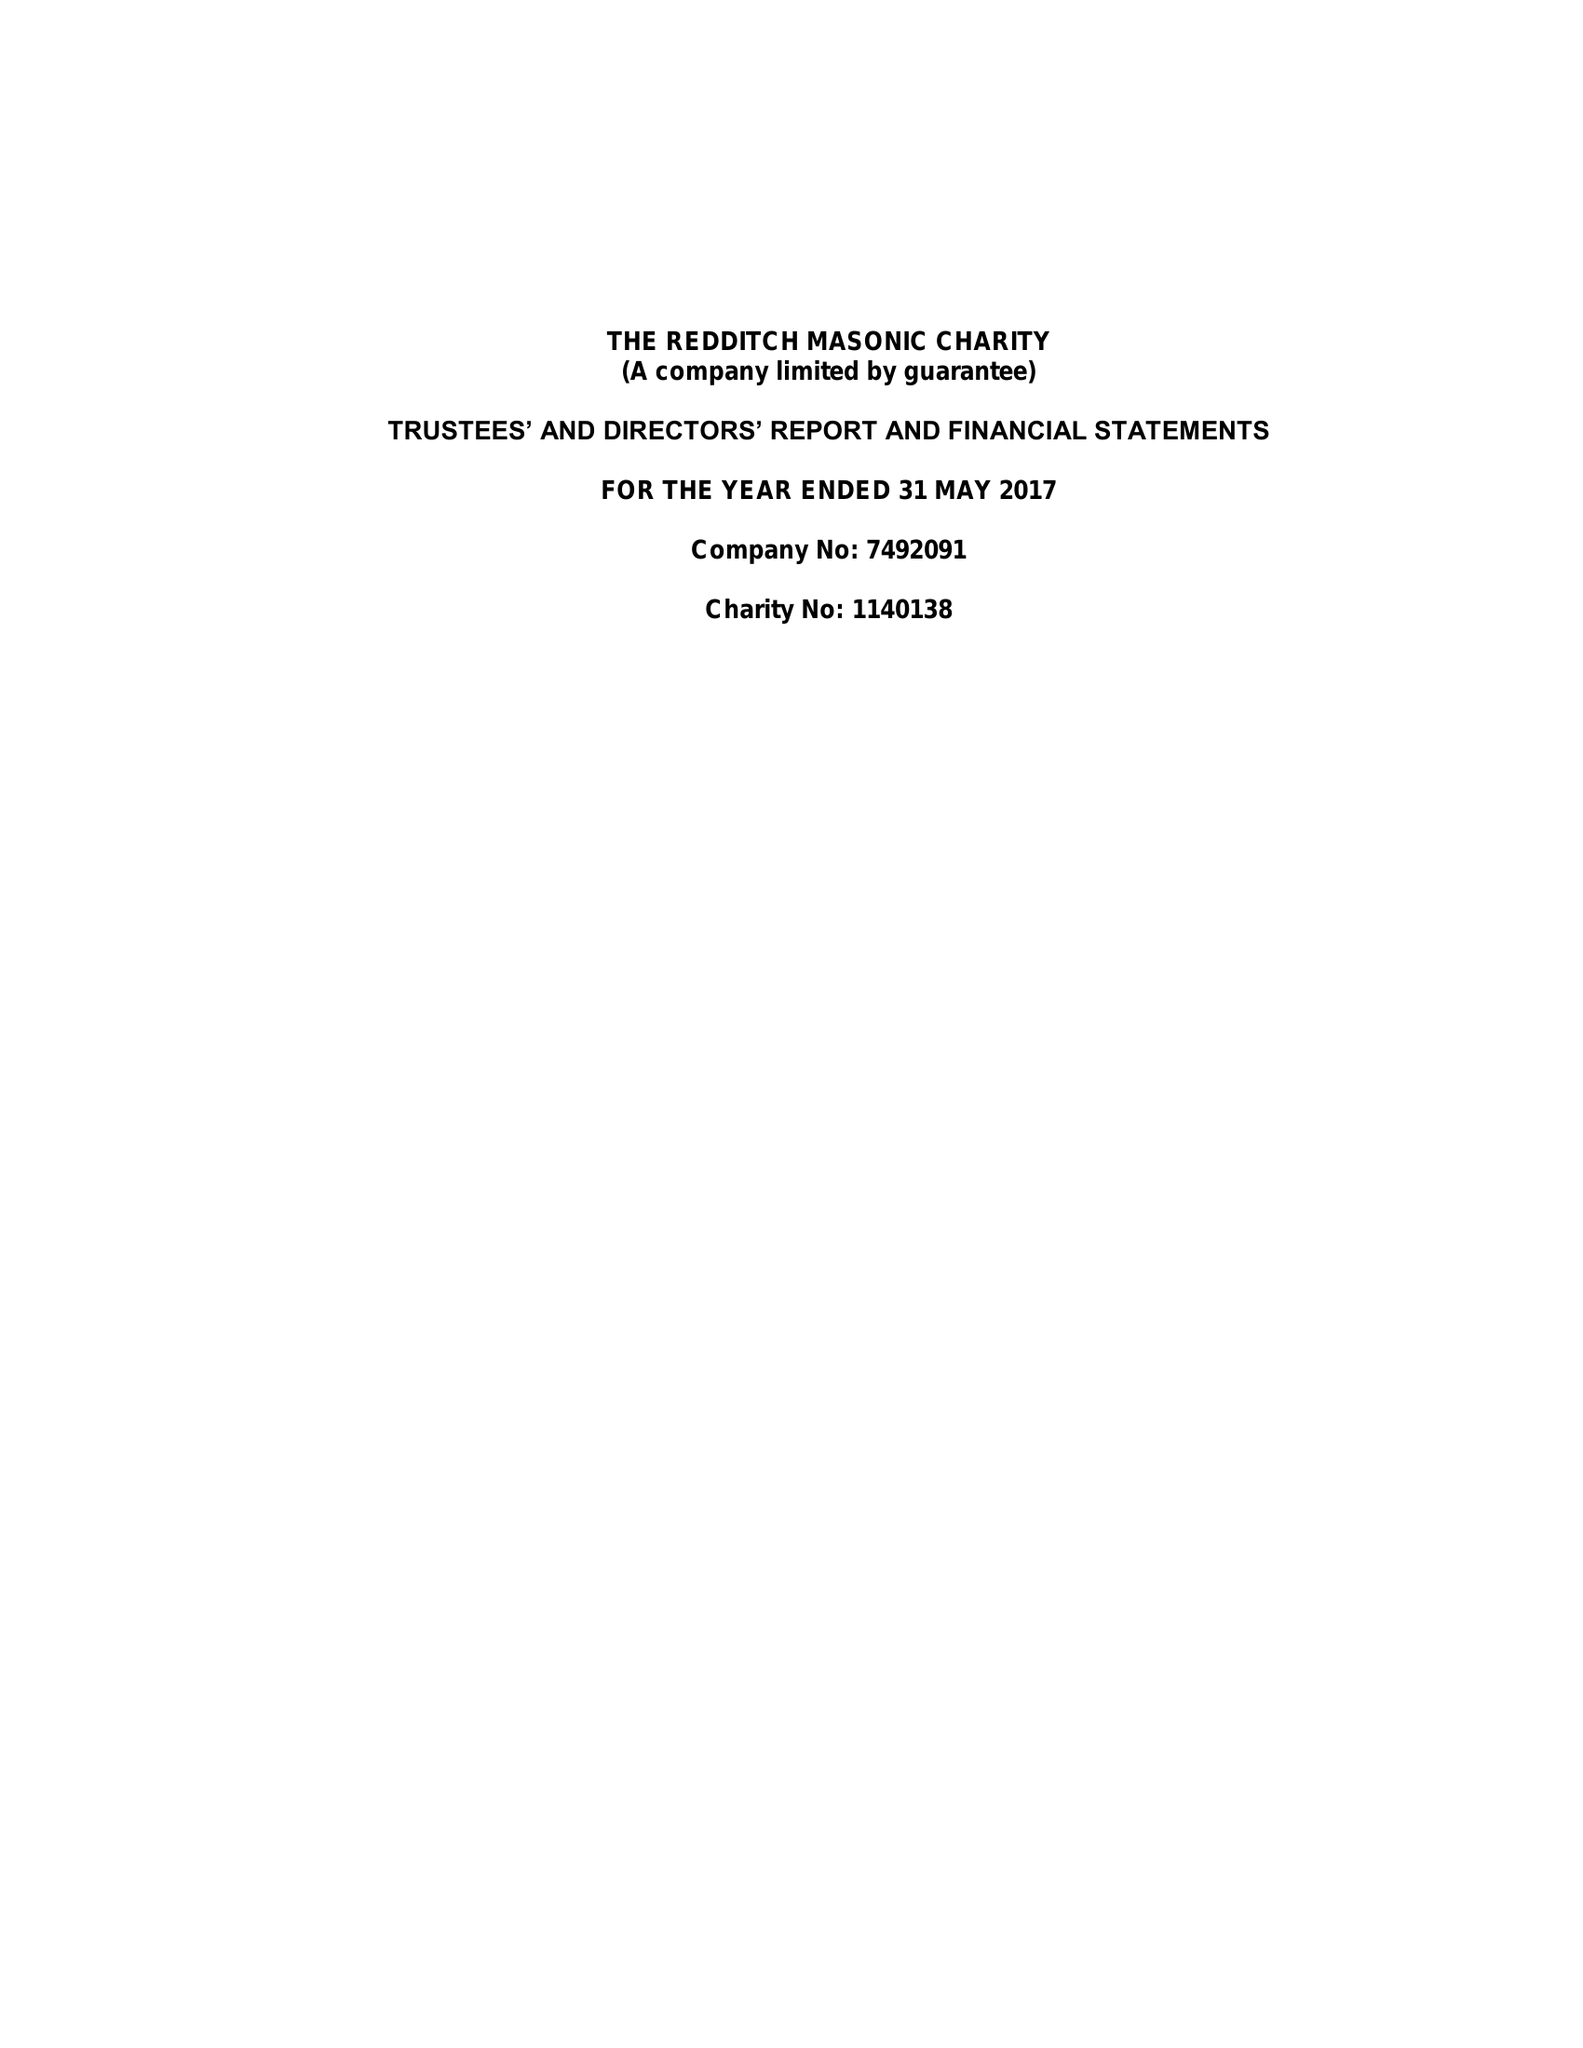What is the value for the spending_annually_in_british_pounds?
Answer the question using a single word or phrase. 56199.00 